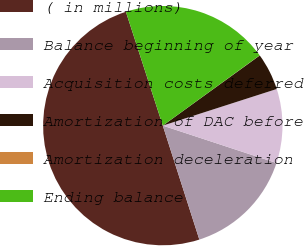<chart> <loc_0><loc_0><loc_500><loc_500><pie_chart><fcel>( in millions)<fcel>Balance beginning of year<fcel>Acquisition costs deferred<fcel>Amortization of DAC before<fcel>Amortization deceleration<fcel>Ending balance<nl><fcel>49.95%<fcel>15.0%<fcel>10.01%<fcel>5.02%<fcel>0.02%<fcel>20.0%<nl></chart> 